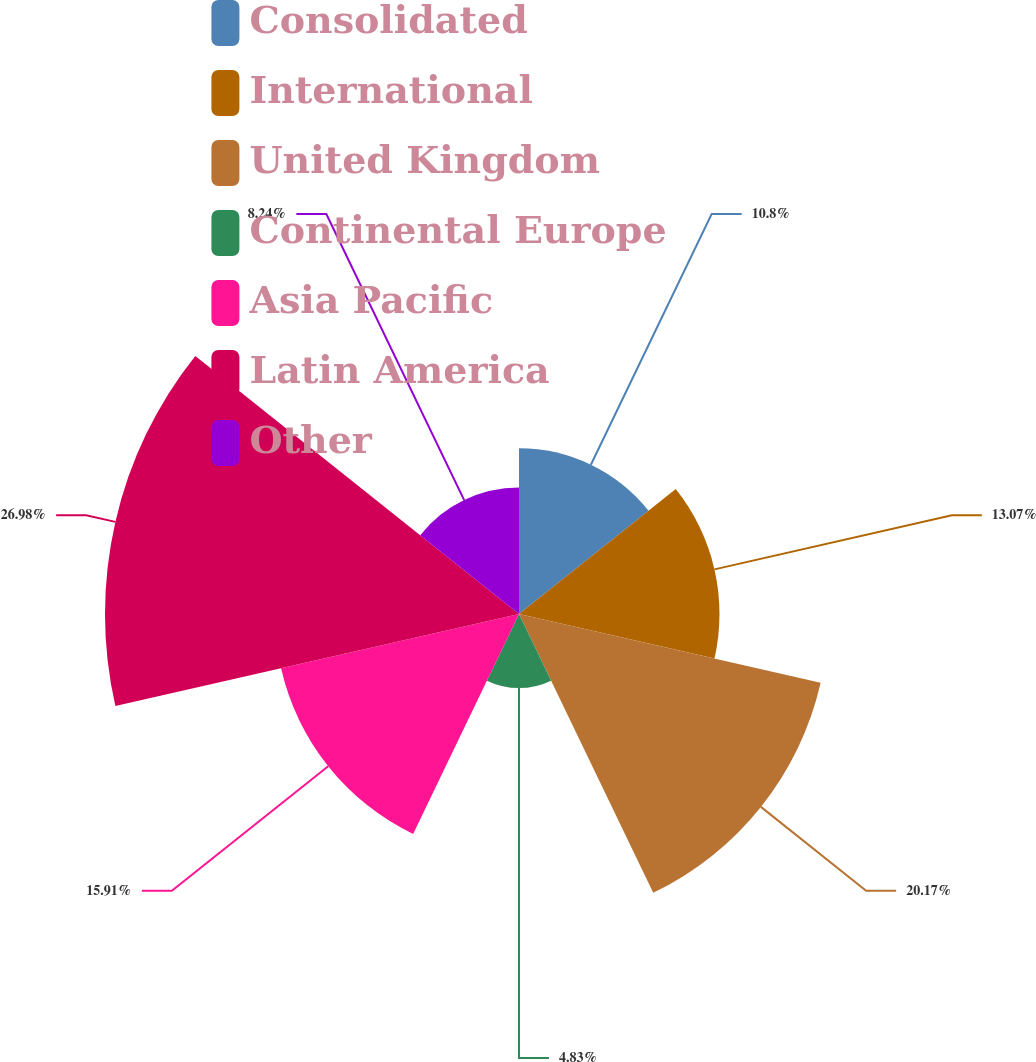<chart> <loc_0><loc_0><loc_500><loc_500><pie_chart><fcel>Consolidated<fcel>International<fcel>United Kingdom<fcel>Continental Europe<fcel>Asia Pacific<fcel>Latin America<fcel>Other<nl><fcel>10.8%<fcel>13.07%<fcel>20.17%<fcel>4.83%<fcel>15.91%<fcel>26.99%<fcel>8.24%<nl></chart> 